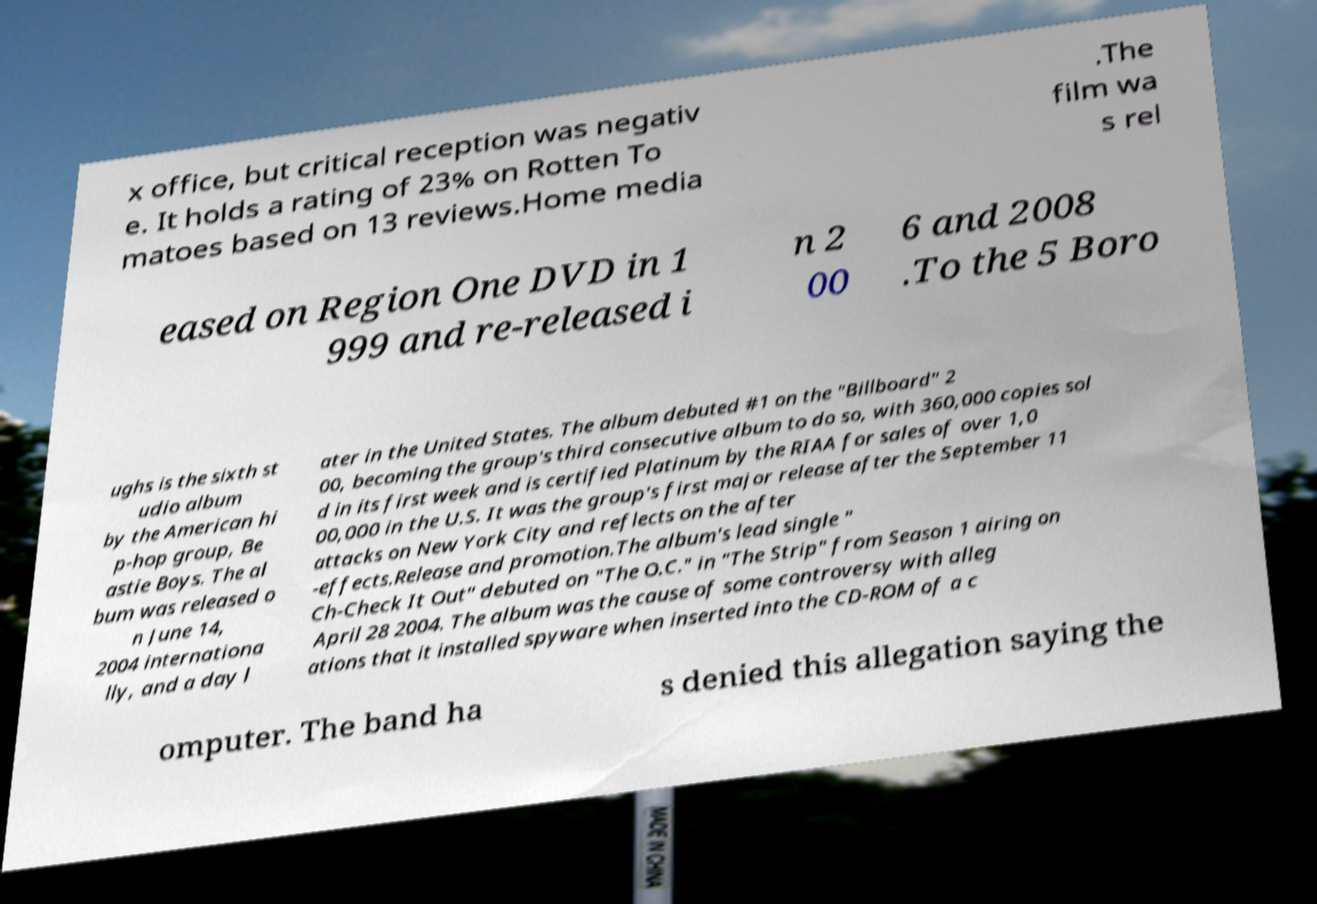For documentation purposes, I need the text within this image transcribed. Could you provide that? x office, but critical reception was negativ e. It holds a rating of 23% on Rotten To matoes based on 13 reviews.Home media .The film wa s rel eased on Region One DVD in 1 999 and re-released i n 2 00 6 and 2008 .To the 5 Boro ughs is the sixth st udio album by the American hi p-hop group, Be astie Boys. The al bum was released o n June 14, 2004 internationa lly, and a day l ater in the United States. The album debuted #1 on the "Billboard" 2 00, becoming the group's third consecutive album to do so, with 360,000 copies sol d in its first week and is certified Platinum by the RIAA for sales of over 1,0 00,000 in the U.S. It was the group's first major release after the September 11 attacks on New York City and reflects on the after -effects.Release and promotion.The album's lead single " Ch-Check It Out" debuted on "The O.C." in "The Strip" from Season 1 airing on April 28 2004. The album was the cause of some controversy with alleg ations that it installed spyware when inserted into the CD-ROM of a c omputer. The band ha s denied this allegation saying the 